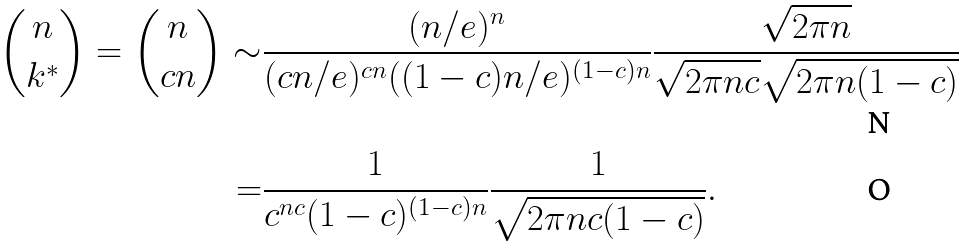<formula> <loc_0><loc_0><loc_500><loc_500>\binom { n } { k ^ { * } } = \binom { n } { c n } \sim & \frac { ( n / e ) ^ { n } } { ( c n / e ) ^ { c n } ( ( 1 - c ) n / e ) ^ { ( 1 - c ) n } } \frac { \sqrt { 2 \pi n } } { \sqrt { 2 \pi n c } \sqrt { 2 \pi n ( 1 - c ) } } \\ = & \frac { 1 } { c ^ { n c } ( 1 - c ) ^ { ( 1 - c ) n } } \frac { 1 } { \sqrt { 2 \pi n c ( 1 - c ) } } .</formula> 